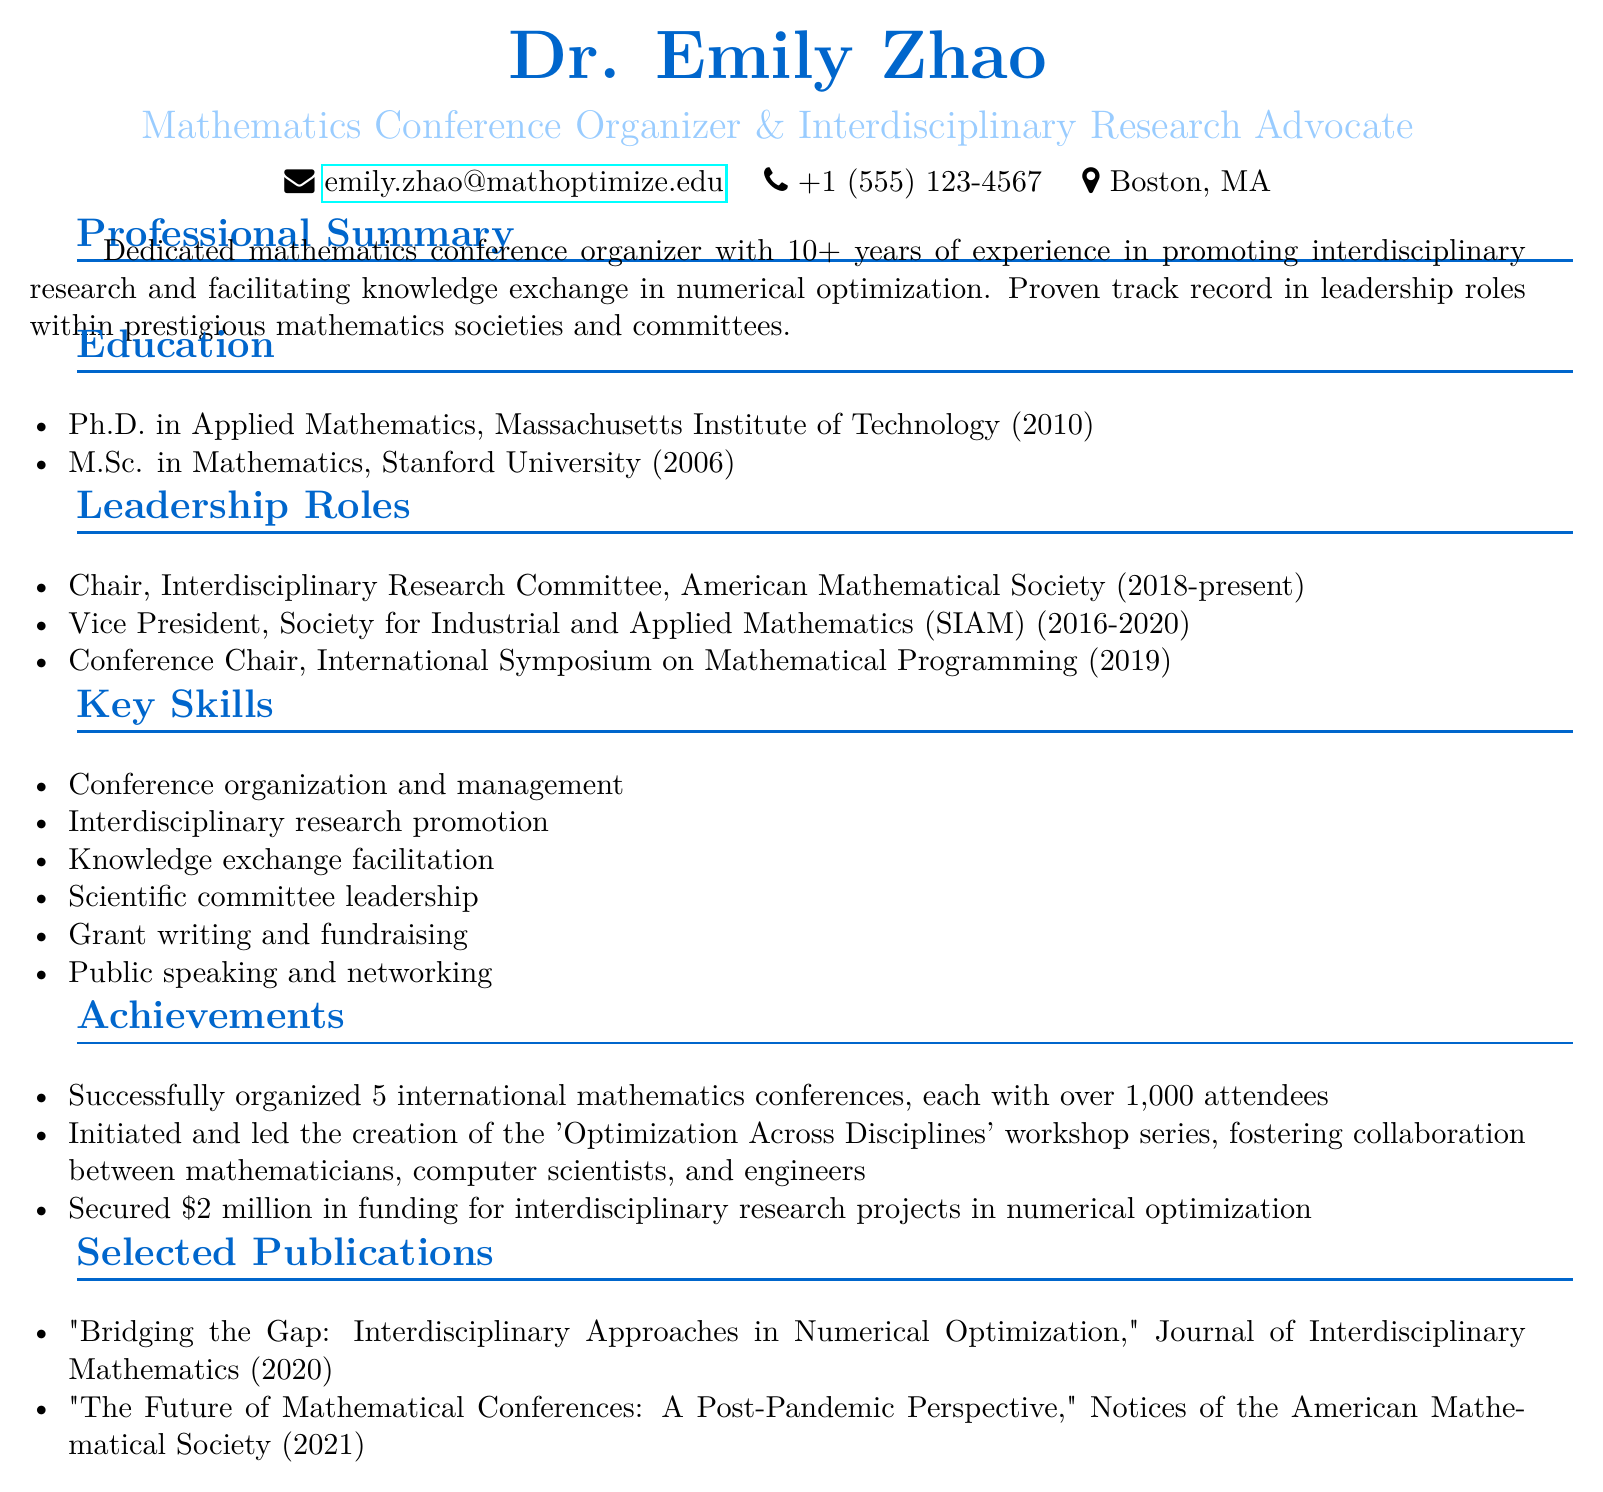What is Dr. Emily Zhao's current position? The document states she is the Chair of the Interdisciplinary Research Committee at the American Mathematical Society.
Answer: Chair, Interdisciplinary Research Committee In which year did Dr. Emily Zhao complete her Ph.D.? The document indicates that she completed her Ph.D. in Applied Mathematics in 2010.
Answer: 2010 How many international mathematics conferences has Dr. Emily Zhao organized? The document mentions that she successfully organized 5 international mathematics conferences.
Answer: 5 What is one of Dr. Emily Zhao's key skills? The document lists several key skills, one of which is conference organization and management.
Answer: Conference organization and management What organization did Dr. Emily Zhao serve as Vice President? The document states she served as Vice President of the Society for Industrial and Applied Mathematics (SIAM).
Answer: Society for Industrial and Applied Mathematics (SIAM) What was the title of Dr. Emily Zhao's publication in 2021? The document provides the title "The Future of Mathematical Conferences: A Post-Pandemic Perspective" for her 2021 publication.
Answer: The Future of Mathematical Conferences: A Post-Pandemic Perspective What grant amount did Dr. Emily Zhao secure for interdisciplinary research projects? The document notes that she secured $2 million in funding for research projects.
Answer: $2 million Which institution did Dr. Emily Zhao attend for her M.Sc. in Mathematics? The document indicates she attended Stanford University for her M.Sc.
Answer: Stanford University What is Dr. Emily Zhao's email address? The document provides her email address as emily.zhao@mathoptimize.edu.
Answer: emily.zhao@mathoptimize.edu 